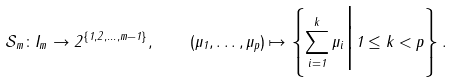Convert formula to latex. <formula><loc_0><loc_0><loc_500><loc_500>\mathcal { S } _ { m } \colon I _ { m } \rightarrow 2 ^ { \{ 1 , 2 , \dots , m - 1 \} } , \quad ( \mu _ { 1 } , \dots , \mu _ { p } ) \mapsto \left \{ \sum _ { i = 1 } ^ { k } \mu _ { i } \Big | 1 \leq k < p \right \} .</formula> 